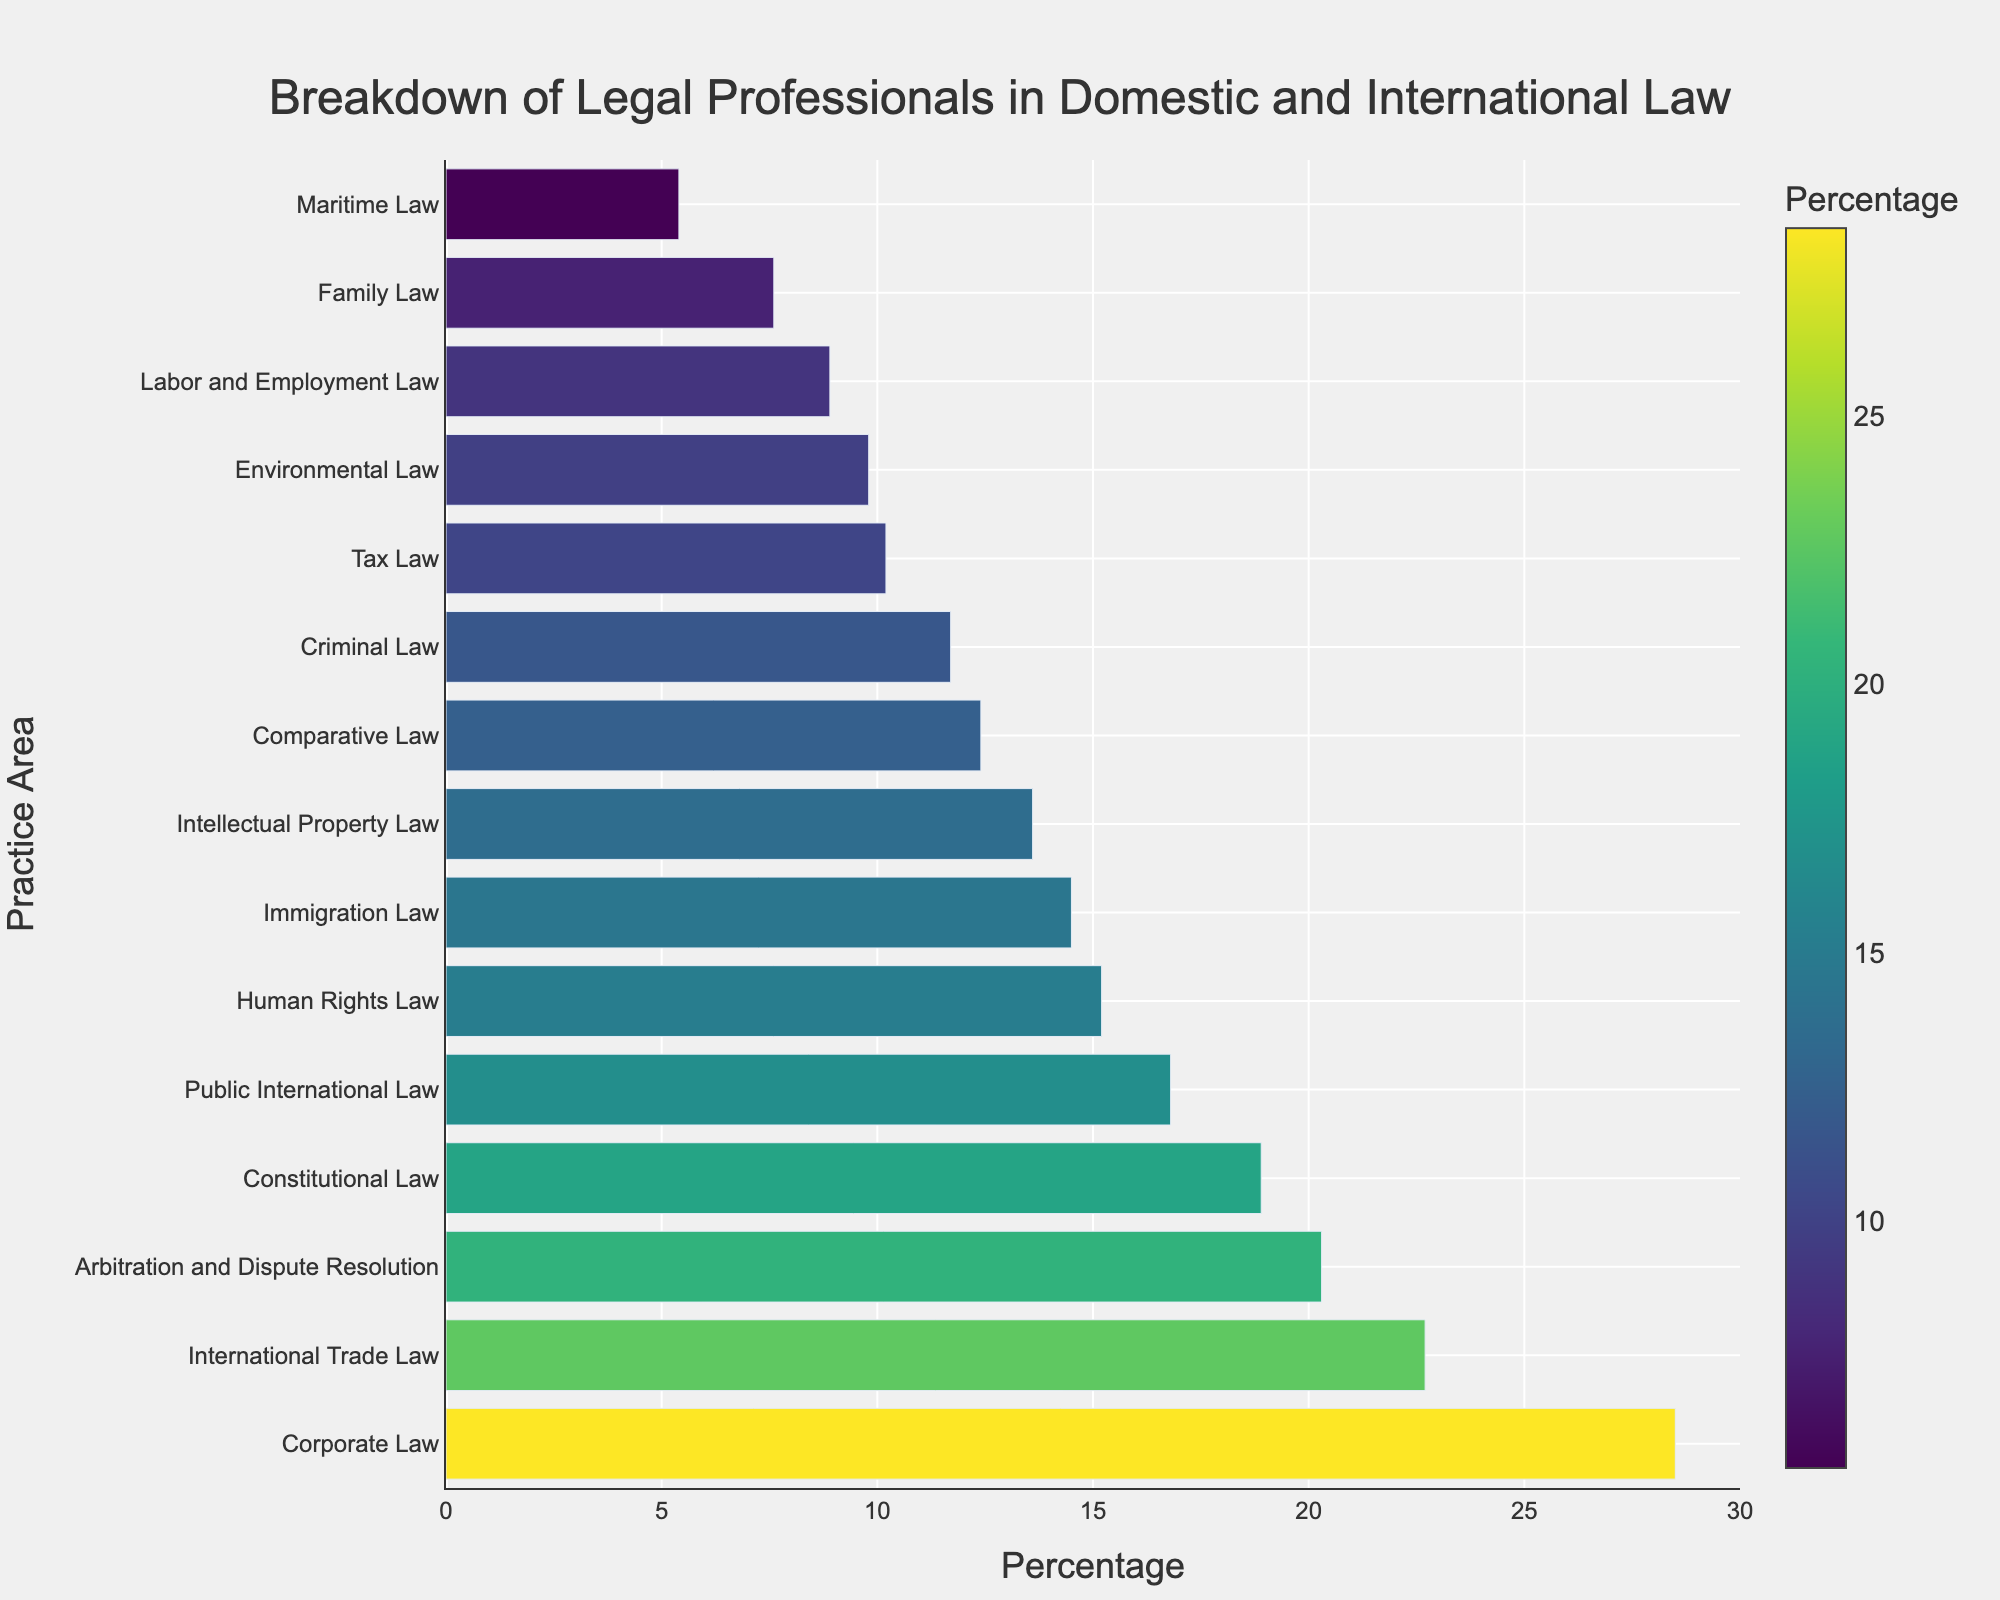What is the practice area with the highest percentage of legal professionals? The visual attribute (length of the bar) of the 'Corporate Law' practice area is the longest in the bar chart, indicating it has the highest percentage.
Answer: Corporate Law What is the combined percentage of professionals in 'Human Rights Law' and 'Immigration Law'? Summing up the percentages for 'Human Rights Law' (15.2%) and 'Immigration Law' (14.5%) gives 15.2% + 14.5%.
Answer: 29.7% Which practice area has a higher percentage of legal professionals, 'Environmental Law' or 'Maritime Law'? Comparing the lengths of the respective bars shows that 'Environmental Law' (9.8%) has a higher percentage than 'Maritime Law' (5.4%).
Answer: Environmental Law What is the difference in percentage between 'Tax Law' and 'Family Law'? The percentage for 'Tax Law' (10.2%) minus that for 'Family Law' (7.6%) is the difference in percentage. Calculating gives 10.2% - 7.6%.
Answer: 2.6% Identify the practice area closest to having a 12% representation. The 'Comparative Law' practice area has a percentage of 12.4%, which is the closest to 12% among the listed areas in the chart.
Answer: Comparative Law Which practice area occupies the median rank in terms of the percentage of legal professionals? Organizing the practice areas by percentage in ascending order, the middle value (8th in the list) being 'Criminal Law' with 11.7%.
Answer: Criminal Law How many practice areas have more than a 15% representation? From the chart, the practice areas surpassing the 15% mark are 'Corporate Law' (28.5%), 'International Trade Law' (22.7%), 'Constitutional Law' (18.9%), 'Arbitration and Dispute Resolution' (20.3%), 'Public International Law' (16.8%), and 'Human Rights Law' (15.2%). Therefore, there are six such practice areas.
Answer: 6 Which practice area just falls within the bottom three ranks? Observing the shortest bars, 'Maritime Law' (5.4%), 'Family Law' (7.6%), and 'Labor and Employment Law' (8.9%) occupy the bottom three, where 'Labor and Employment Law' is the 3rd from the bottom.
Answer: Labor and Employment Law What is the total percentage of legal professionals specializing in 'Arbitration and Dispute Resolution' and 'Public International Law'? Adding the percentages for 'Arbitration and Dispute Resolution' (20.3%) and 'Public International Law' (16.8%) gives 20.3% + 16.8%.
Answer: 37.1% Which is more than Immigration Law, but less than Constitutional Law? The practice area with a percentage greater than 'Immigration Law' (14.5%) but less than 'Constitutional Law' (18.9%) is 'Public International Law' with 16.8%.
Answer: Public International Law 